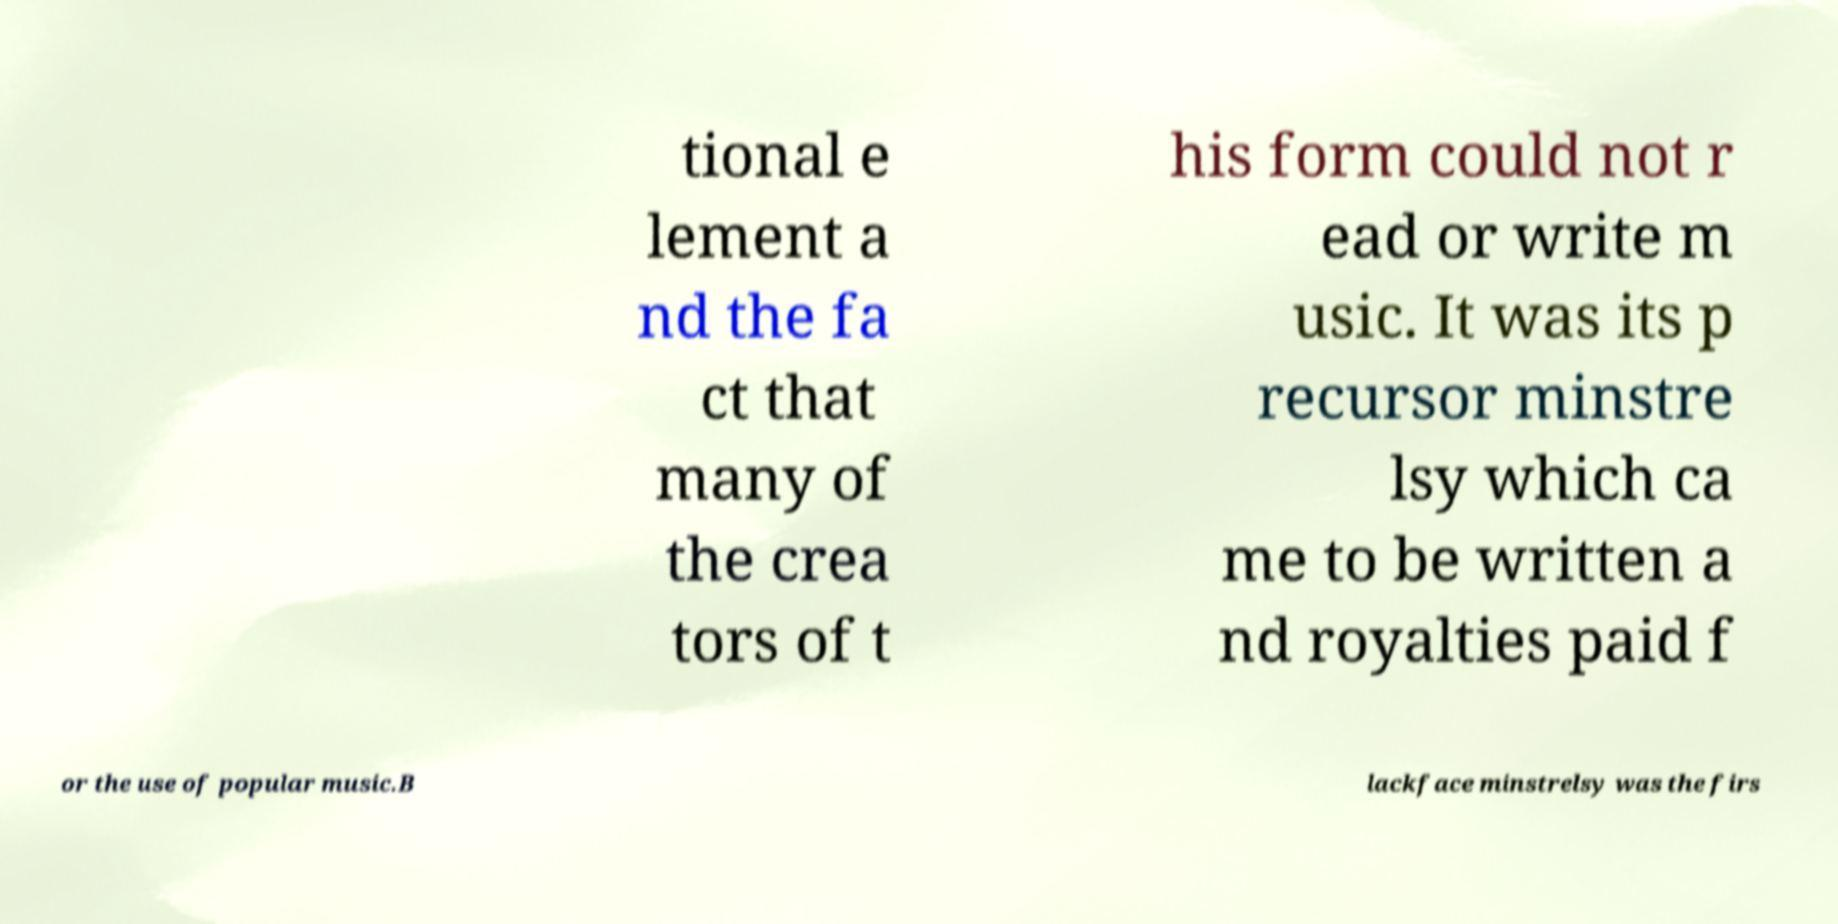What messages or text are displayed in this image? I need them in a readable, typed format. tional e lement a nd the fa ct that many of the crea tors of t his form could not r ead or write m usic. It was its p recursor minstre lsy which ca me to be written a nd royalties paid f or the use of popular music.B lackface minstrelsy was the firs 